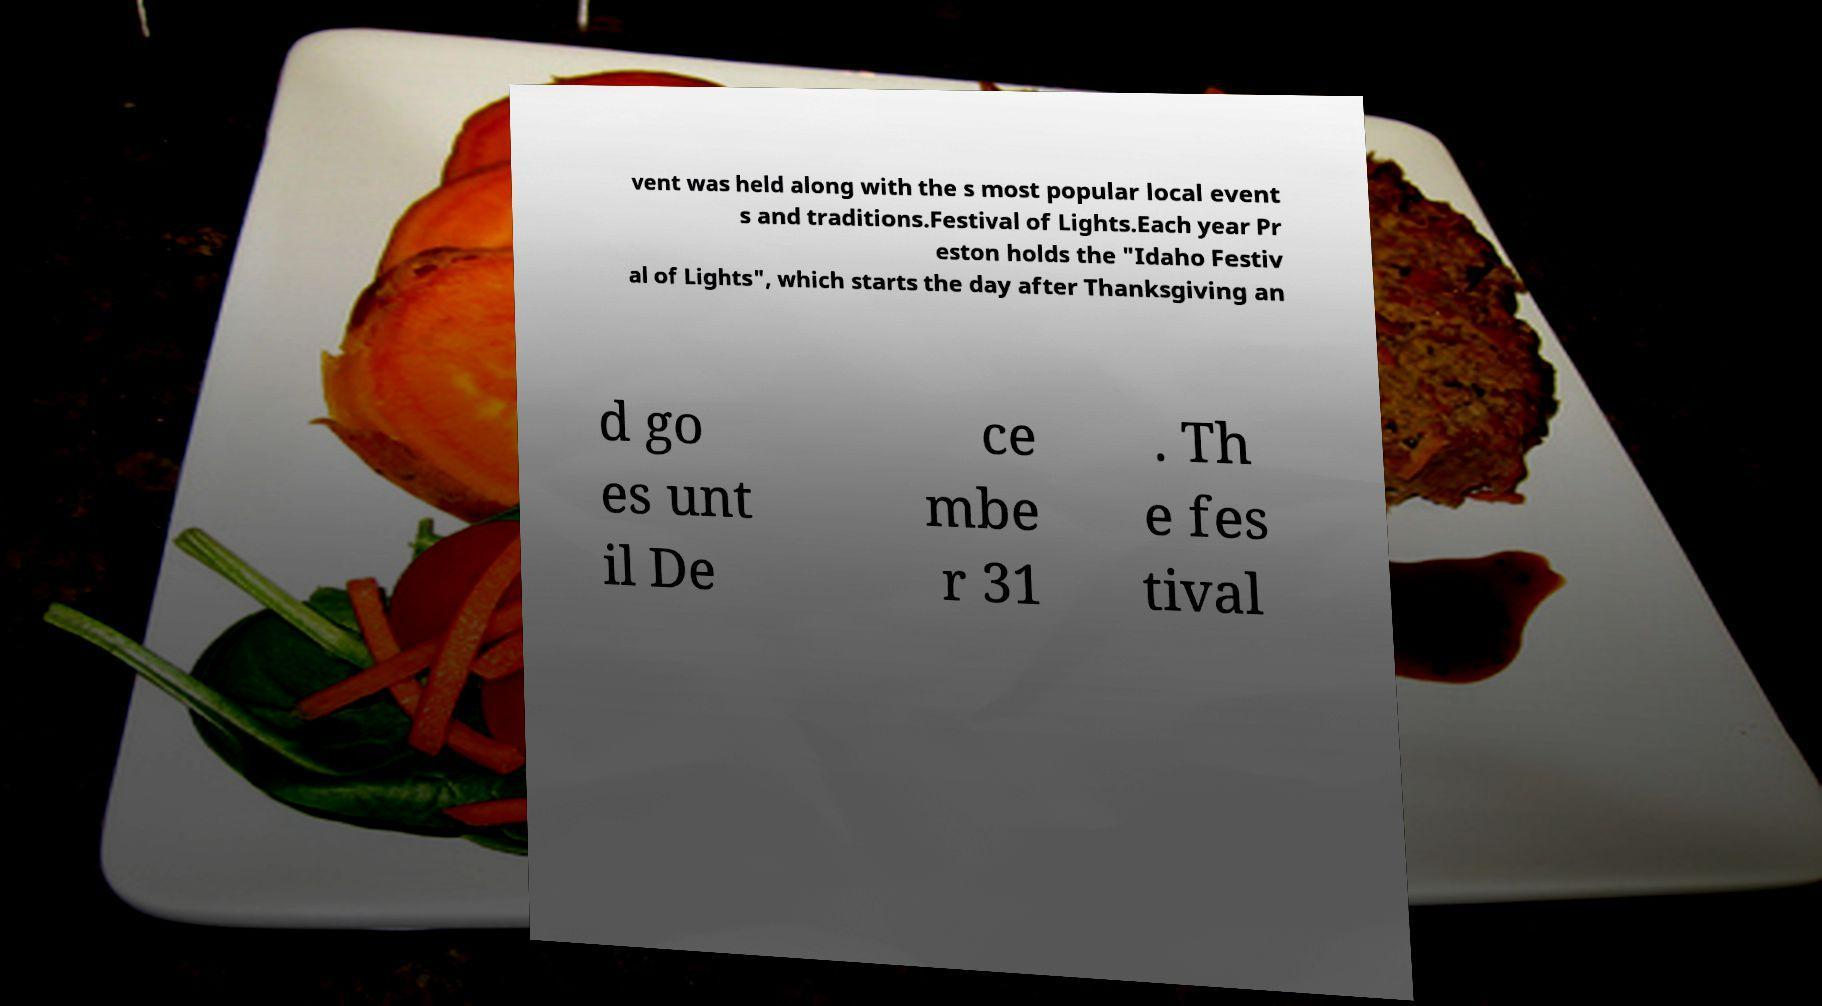For documentation purposes, I need the text within this image transcribed. Could you provide that? vent was held along with the s most popular local event s and traditions.Festival of Lights.Each year Pr eston holds the "Idaho Festiv al of Lights", which starts the day after Thanksgiving an d go es unt il De ce mbe r 31 . Th e fes tival 